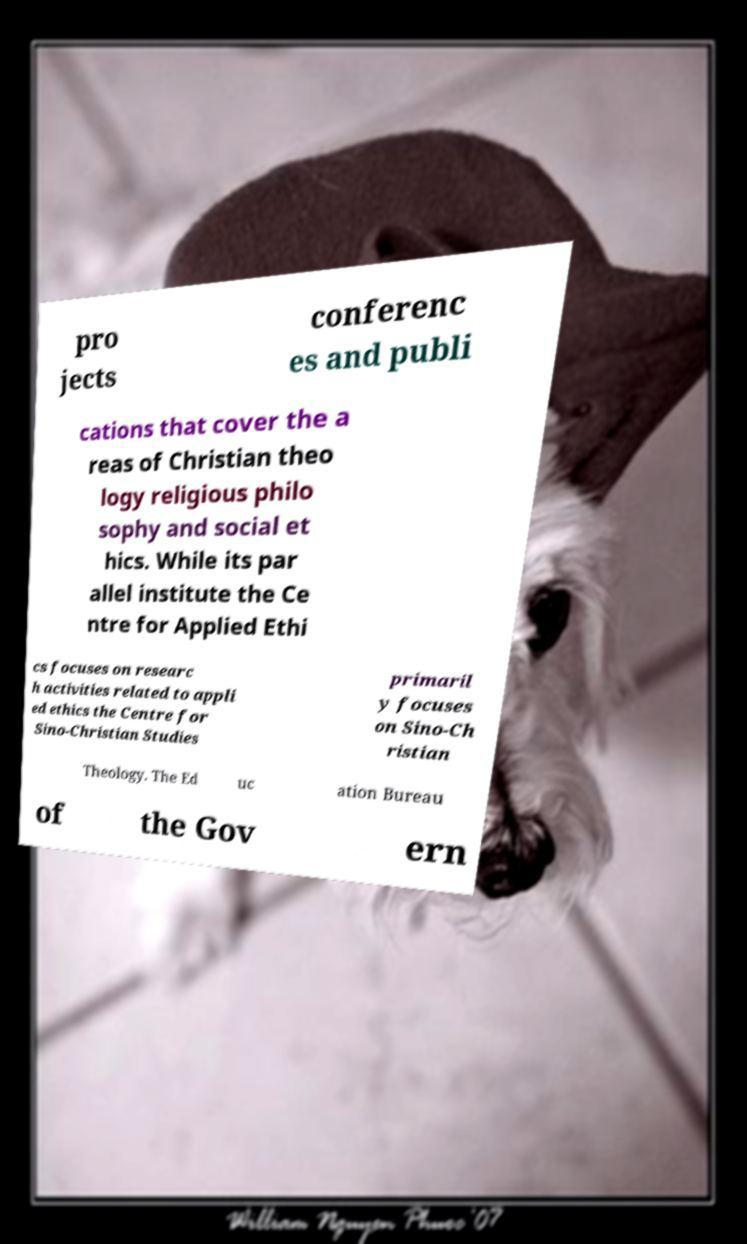Could you extract and type out the text from this image? pro jects conferenc es and publi cations that cover the a reas of Christian theo logy religious philo sophy and social et hics. While its par allel institute the Ce ntre for Applied Ethi cs focuses on researc h activities related to appli ed ethics the Centre for Sino-Christian Studies primaril y focuses on Sino-Ch ristian Theology. The Ed uc ation Bureau of the Gov ern 